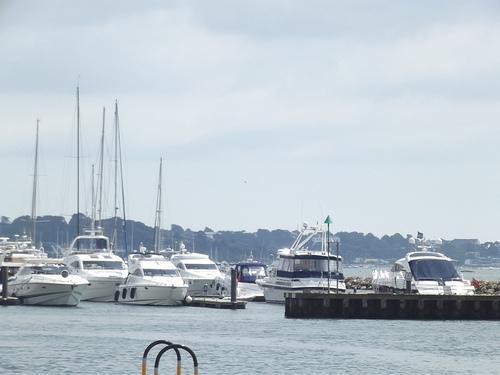How many boats are directly behind the dock?
Give a very brief answer. 2. 